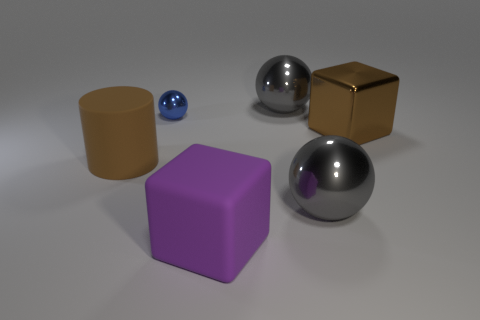Subtract all large metal spheres. How many spheres are left? 1 Add 1 big purple objects. How many objects exist? 7 Subtract all cylinders. How many objects are left? 5 Subtract all tiny blue balls. Subtract all big metal cylinders. How many objects are left? 5 Add 3 large purple matte objects. How many large purple matte objects are left? 4 Add 4 small balls. How many small balls exist? 5 Subtract 0 purple balls. How many objects are left? 6 